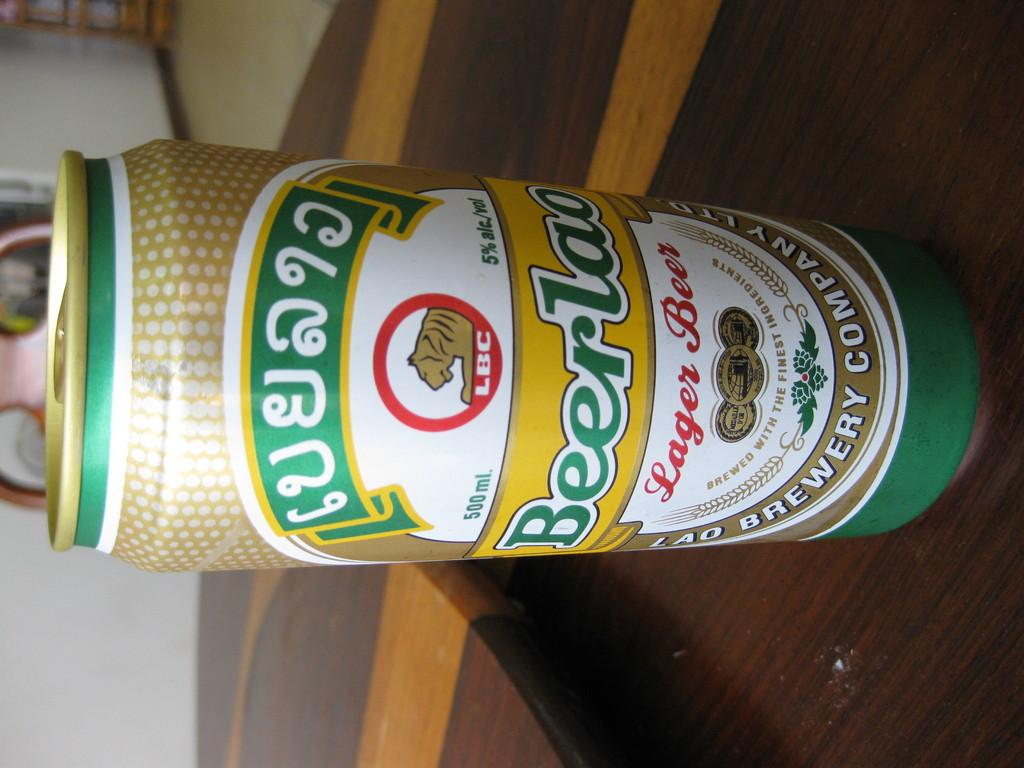<image>
Relay a brief, clear account of the picture shown. Green and yellow beer can which syas "Lager Beer". 